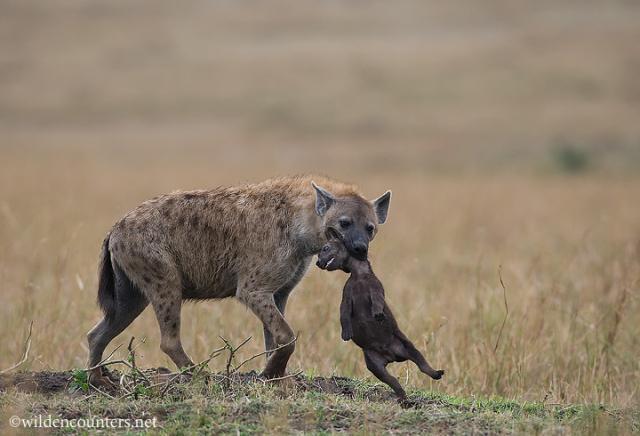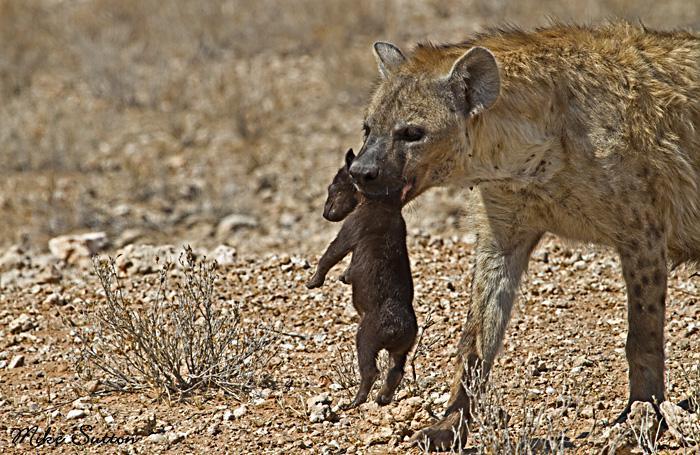The first image is the image on the left, the second image is the image on the right. Assess this claim about the two images: "In at least one image there is a single tan and black spotted hyena walking right holding a small pup in its mouth.". Correct or not? Answer yes or no. Yes. The first image is the image on the left, the second image is the image on the right. For the images displayed, is the sentence "Each image shows one adult hyena carrying at least one pup in its mouth." factually correct? Answer yes or no. Yes. 